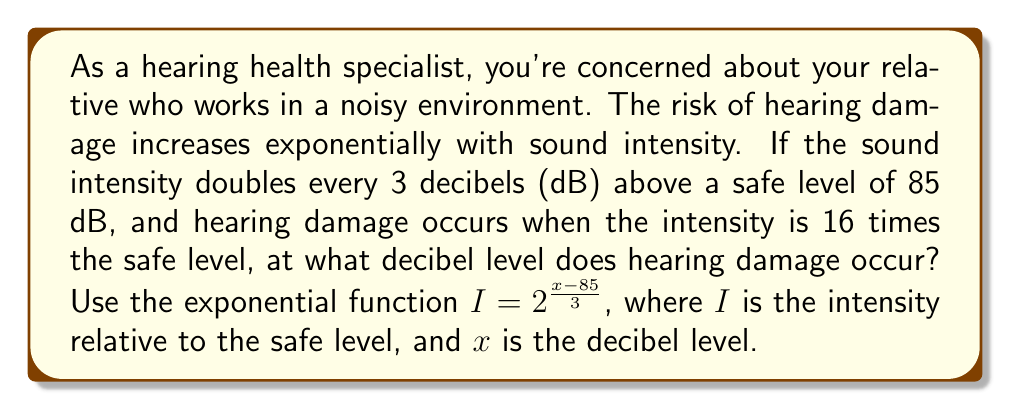Can you answer this question? Let's approach this step-by-step:

1) We're given that hearing damage occurs when the intensity is 16 times the safe level. So, we need to solve for $x$ when $I = 16$.

2) Let's substitute these values into our exponential function:

   $16 = 2^{\frac{x-85}{3}}$

3) To solve this, we can use logarithms. Let's take the logarithm base 2 of both sides:

   $\log_2(16) = \log_2(2^{\frac{x-85}{3}})$

4) Using the logarithm property $\log_a(a^x) = x$, we can simplify the right side:

   $\log_2(16) = \frac{x-85}{3}$

5) We know that $\log_2(16) = 4$ because $2^4 = 16$. So:

   $4 = \frac{x-85}{3}$

6) Multiply both sides by 3:

   $12 = x-85$

7) Add 85 to both sides:

   $97 = x$

Therefore, hearing damage occurs at 97 dB.
Answer: 97 dB 